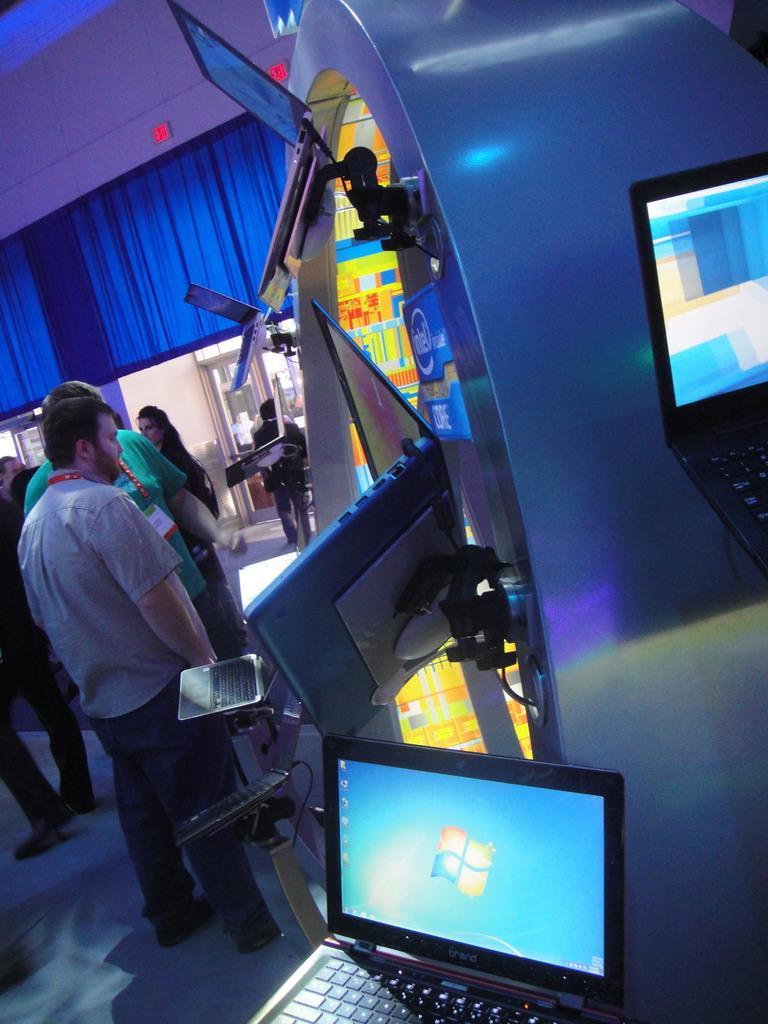How would you summarize this image in a sentence or two? In this picture I can see laptops with stands, there are group of people standing, and in the background there are some objects. 